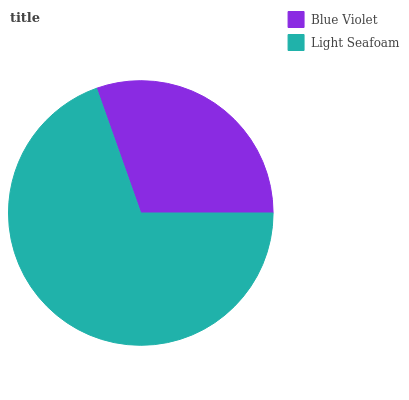Is Blue Violet the minimum?
Answer yes or no. Yes. Is Light Seafoam the maximum?
Answer yes or no. Yes. Is Light Seafoam the minimum?
Answer yes or no. No. Is Light Seafoam greater than Blue Violet?
Answer yes or no. Yes. Is Blue Violet less than Light Seafoam?
Answer yes or no. Yes. Is Blue Violet greater than Light Seafoam?
Answer yes or no. No. Is Light Seafoam less than Blue Violet?
Answer yes or no. No. Is Light Seafoam the high median?
Answer yes or no. Yes. Is Blue Violet the low median?
Answer yes or no. Yes. Is Blue Violet the high median?
Answer yes or no. No. Is Light Seafoam the low median?
Answer yes or no. No. 